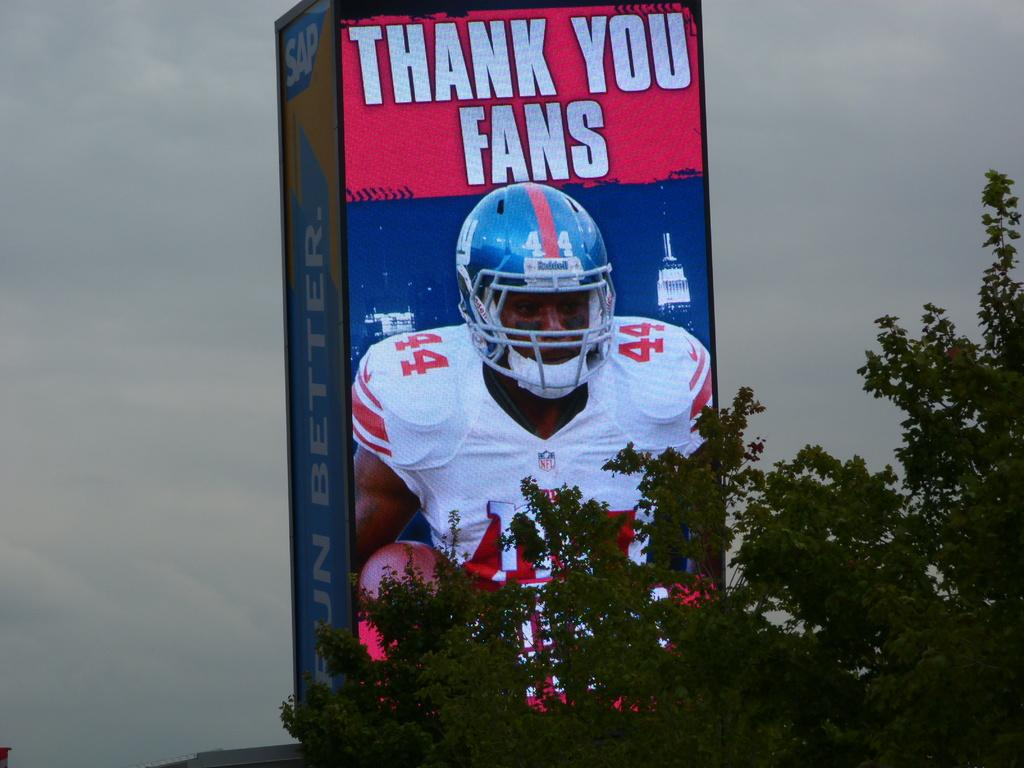What is on the board in the image? There is a poster on a board in the image. What is depicted on the poster? The poster depicts trees. What can be seen in the background of the image? The sky is visible in the background of the image. How many wrens are sitting on the branches of the trees depicted on the poster? There are no wrens depicted on the poster; it only shows trees. Is the family of the person who took the image visible in the image? There is no reference to a family or any people in the image, only a poster with trees and the sky in the background. 